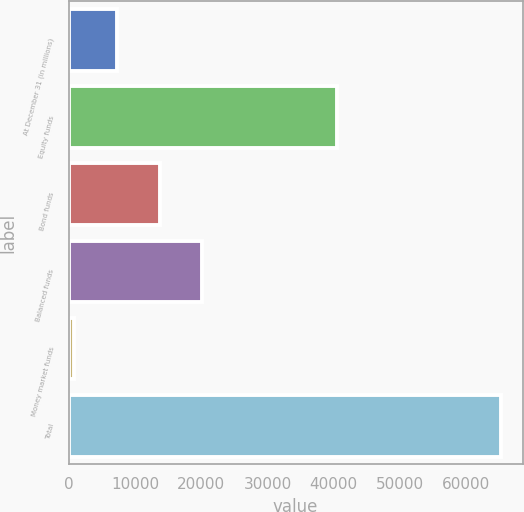Convert chart to OTSL. <chart><loc_0><loc_0><loc_500><loc_500><bar_chart><fcel>At December 31 (in millions)<fcel>Equity funds<fcel>Bond funds<fcel>Balanced funds<fcel>Money market funds<fcel>Total<nl><fcel>7300.9<fcel>40497<fcel>13734.8<fcel>20168.7<fcel>867<fcel>65206<nl></chart> 